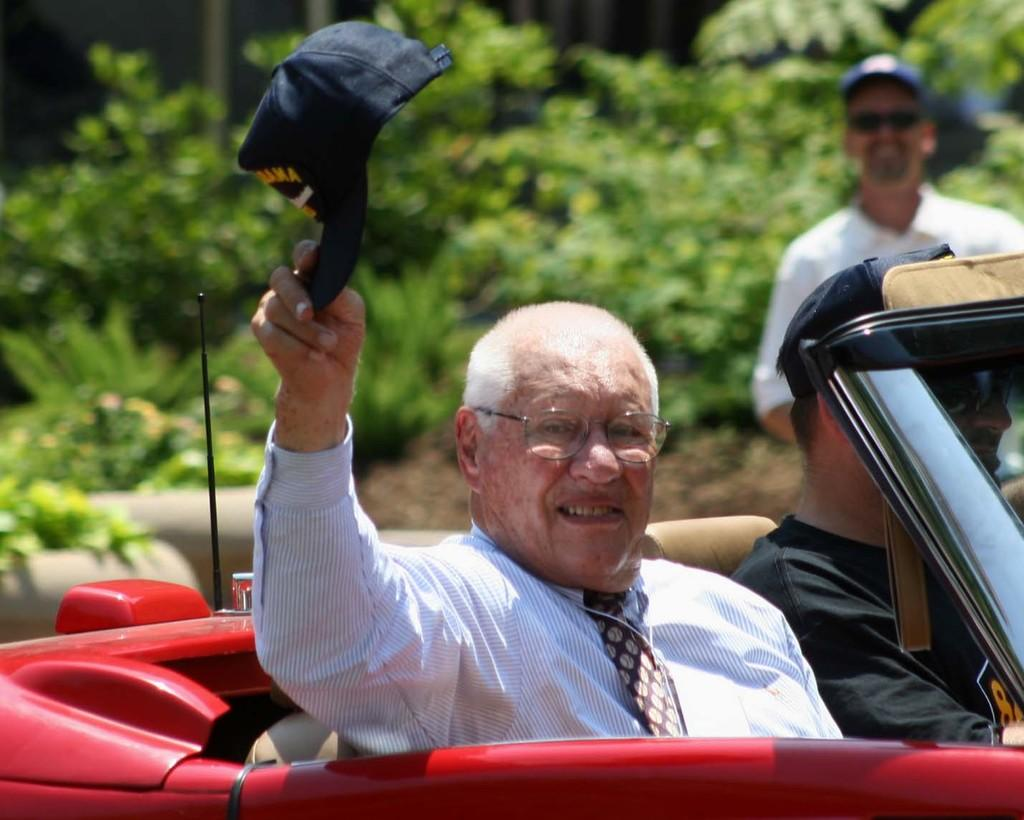What type of natural elements can be seen in the image? There are trees in the image. How many people are present in the image? There are three people in the image. What are two of the people doing in the image? Two of the people are sitting in a red color car. How many apples can be seen on the tree in the image? There are no apples visible in the image; only trees are mentioned. What type of experience can be gained from sitting in the red color car in the image? The image does not provide information about the experience of sitting in the car, as it only shows the people sitting in it. 